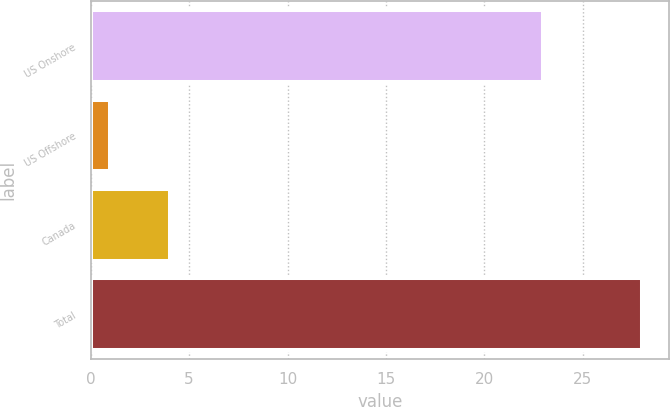Convert chart. <chart><loc_0><loc_0><loc_500><loc_500><bar_chart><fcel>US Onshore<fcel>US Offshore<fcel>Canada<fcel>Total<nl><fcel>23<fcel>1<fcel>4<fcel>28<nl></chart> 